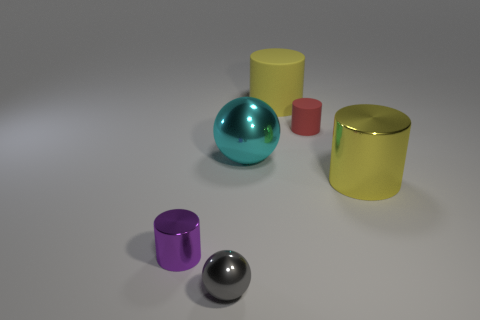What material is the large cyan sphere?
Ensure brevity in your answer.  Metal. There is a metal thing that is in front of the small metal cylinder; how big is it?
Give a very brief answer. Small. What material is the small cylinder that is to the left of the shiny sphere that is on the right side of the tiny metal thing that is in front of the tiny shiny cylinder?
Offer a terse response. Metal. Does the small red thing have the same shape as the cyan metallic thing?
Offer a terse response. No. What number of metal things are large yellow cylinders or big cyan spheres?
Keep it short and to the point. 2. How many tiny gray rubber blocks are there?
Ensure brevity in your answer.  0. There is a ball that is the same size as the purple metallic cylinder; what is its color?
Provide a short and direct response. Gray. Does the red rubber cylinder have the same size as the yellow metallic object?
Your response must be concise. No. There is a big thing that is the same color as the big matte cylinder; what shape is it?
Keep it short and to the point. Cylinder. There is a cyan thing; does it have the same size as the yellow thing that is right of the big yellow rubber cylinder?
Your response must be concise. Yes. 